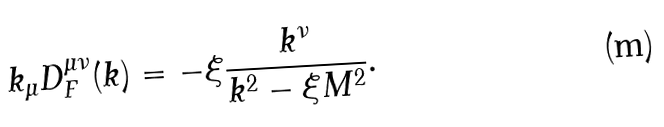<formula> <loc_0><loc_0><loc_500><loc_500>k _ { \mu } D _ { F } ^ { \mu \nu } ( k ) = - \xi \frac { k ^ { \nu } } { k ^ { 2 } - \xi M ^ { 2 } } .</formula> 